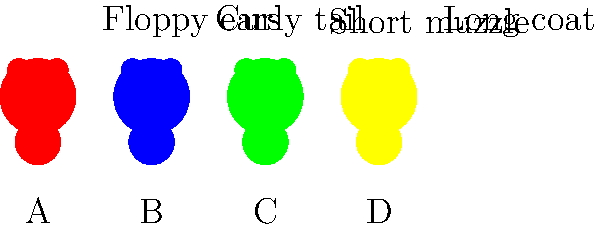Which of the following physical traits is most likely to be associated with an endangered dog breed, considering that many rare breeds have retained primitive or unique characteristics? To answer this question, we need to consider the characteristics of endangered dog breeds:

1. Many endangered dog breeds have retained primitive or unique characteristics that are less common in popular breeds.
2. These traits often reflect the original purpose or environment of the breed.
3. Let's analyze each trait:

   A. Floppy ears: Common in many popular breeds, less likely to be a distinguishing feature of an endangered breed.
   B. Curly tail: More common in primitive or spitz-type breeds, which are often less altered by selective breeding.
   C. Short muzzle: Often a result of selective breeding for aesthetics, less likely in endangered breeds.
   D. Long coat: While present in some rare breeds, it's also common in many popular breeds.

4. Among these options, the curly tail (B) is most likely to be associated with endangered breeds because:
   - It's a primitive trait found in many ancient and less-altered dog breeds.
   - It's less common in popular, highly bred dog breeds.
   - Many endangered breeds, especially those from Arctic or northern regions, retain this feature.

Therefore, the curly tail is the most likely trait to be associated with an endangered dog breed from the given options.
Answer: Curly tail 